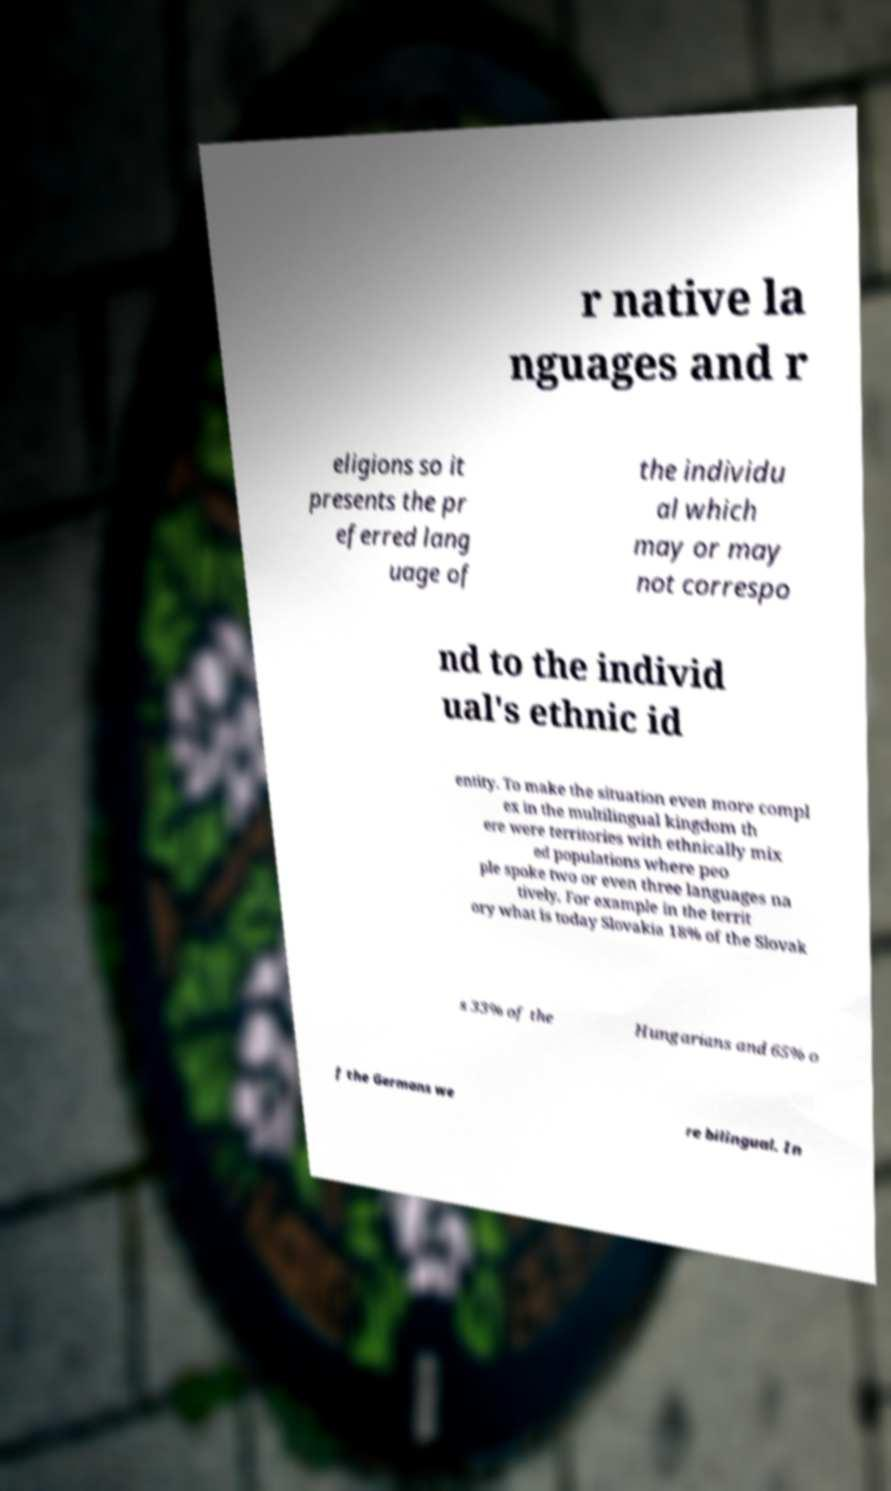Can you read and provide the text displayed in the image?This photo seems to have some interesting text. Can you extract and type it out for me? r native la nguages and r eligions so it presents the pr eferred lang uage of the individu al which may or may not correspo nd to the individ ual's ethnic id entity. To make the situation even more compl ex in the multilingual kingdom th ere were territories with ethnically mix ed populations where peo ple spoke two or even three languages na tively. For example in the territ ory what is today Slovakia 18% of the Slovak s 33% of the Hungarians and 65% o f the Germans we re bilingual. In 